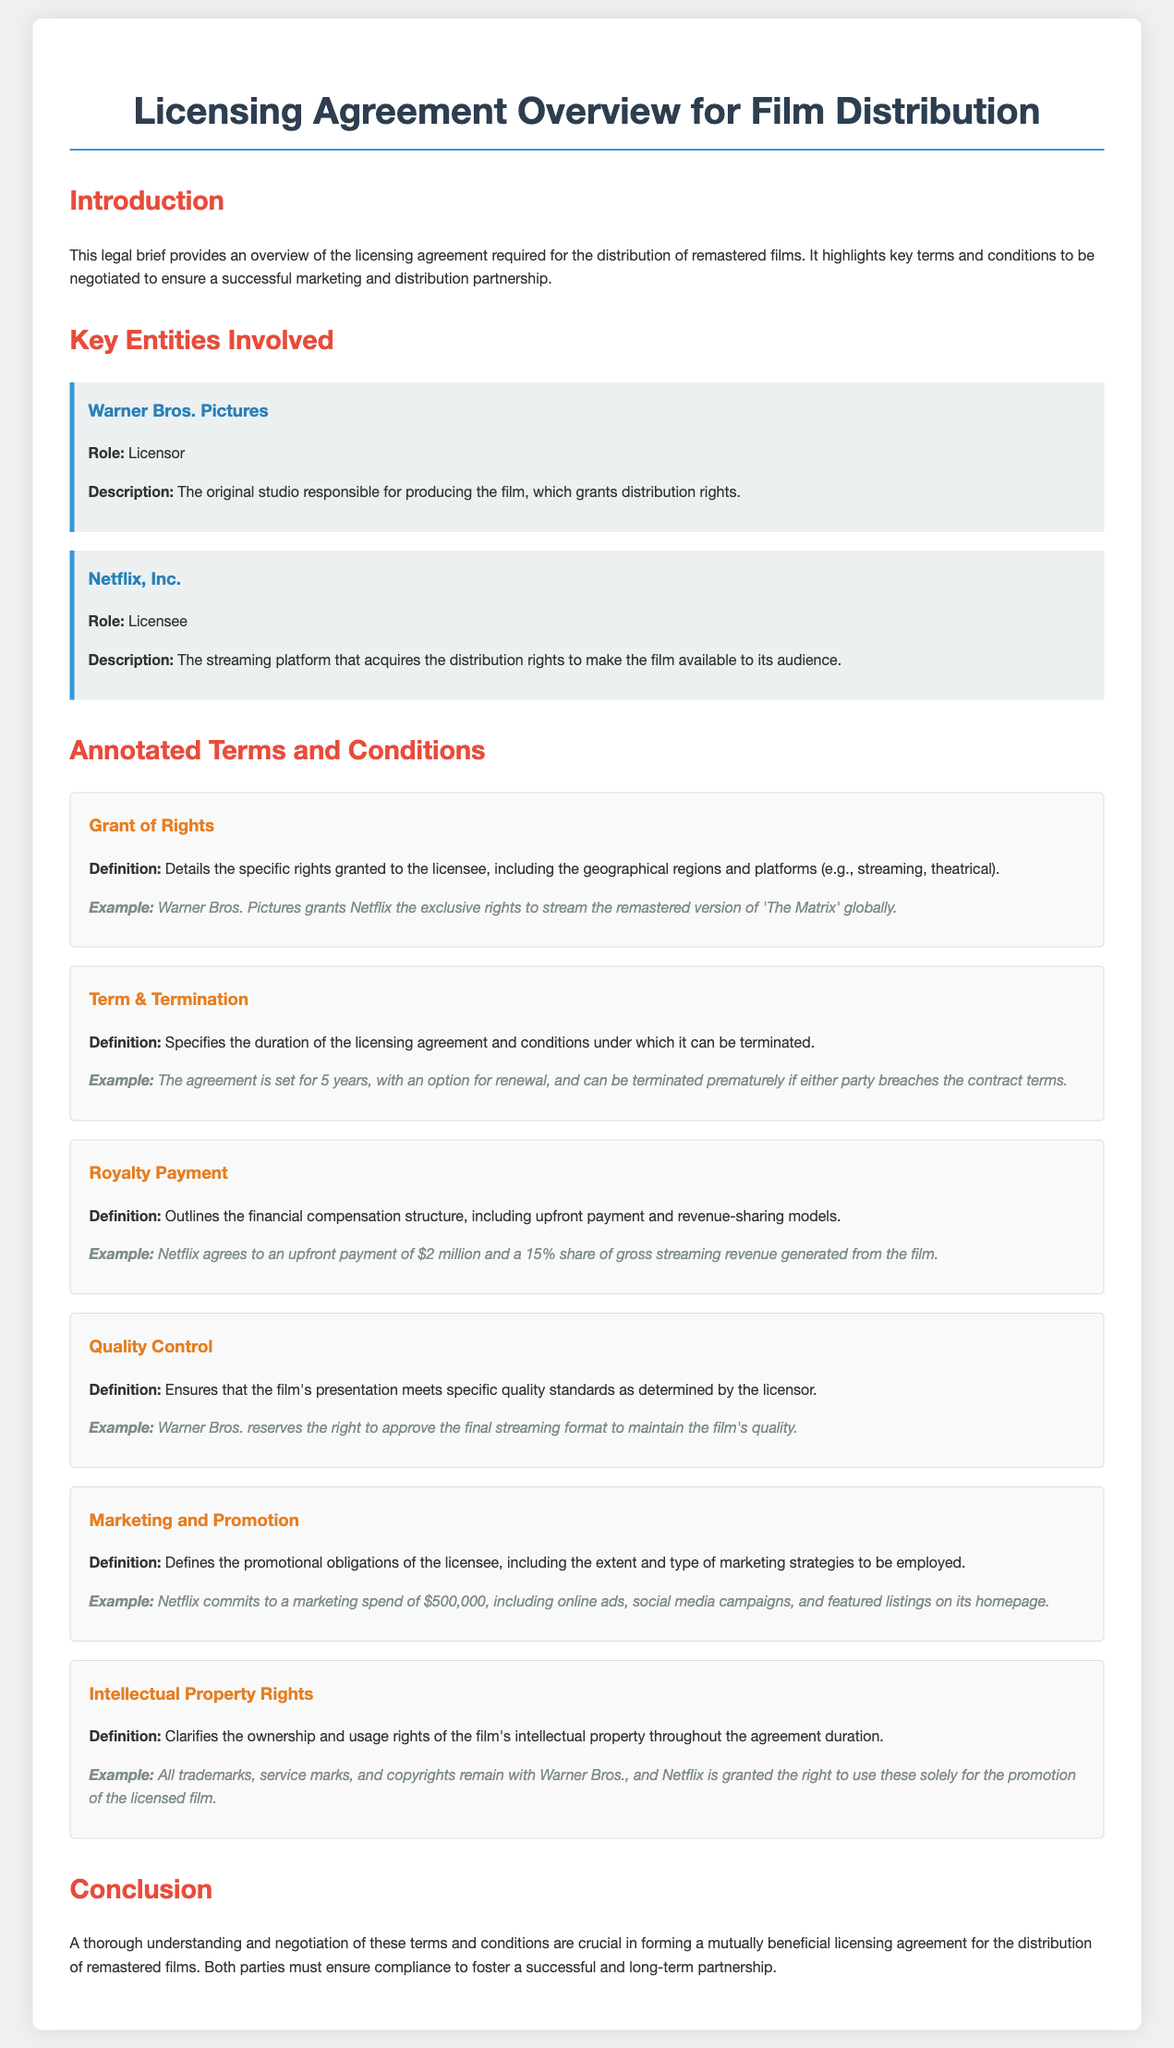what is the role of Warner Bros. Pictures? Warner Bros. Pictures acts as the licensor in the licensing agreement, responsible for granting distribution rights.
Answer: Licensor what is the duration of the licensing agreement? The duration of the licensing agreement is specified to last for 5 years, with an option for renewal.
Answer: 5 years what is the upfront payment agreed by Netflix? The document states that Netflix agrees to an upfront payment as part of the royalty payment structure.
Answer: $2 million what is the marketing spend commitment by Netflix? The document specifies the amount Netflix commits to spending on marketing for the film.
Answer: $500,000 what rights does Warner Bros. Pictures retain over intellectual property? The licensing agreement clarifies the ownership and usage rights of the film's intellectual property throughout the agreement duration.
Answer: All trademarks, service marks, and copyrights what is one of the conditions under which the agreement can be terminated? The licensing agreement specifies conditions that allow either party to terminate the agreement prematurely.
Answer: Breach of contract who is responsible for quality control in the film's presentation? The document indicates who maintains control over quality standards for the film's presentation.
Answer: Warner Bros what must be approved to maintain the film's quality? The document specifies that approval is needed for maintaining certain aspects of the film's quality as per the agreement.
Answer: Final streaming format 